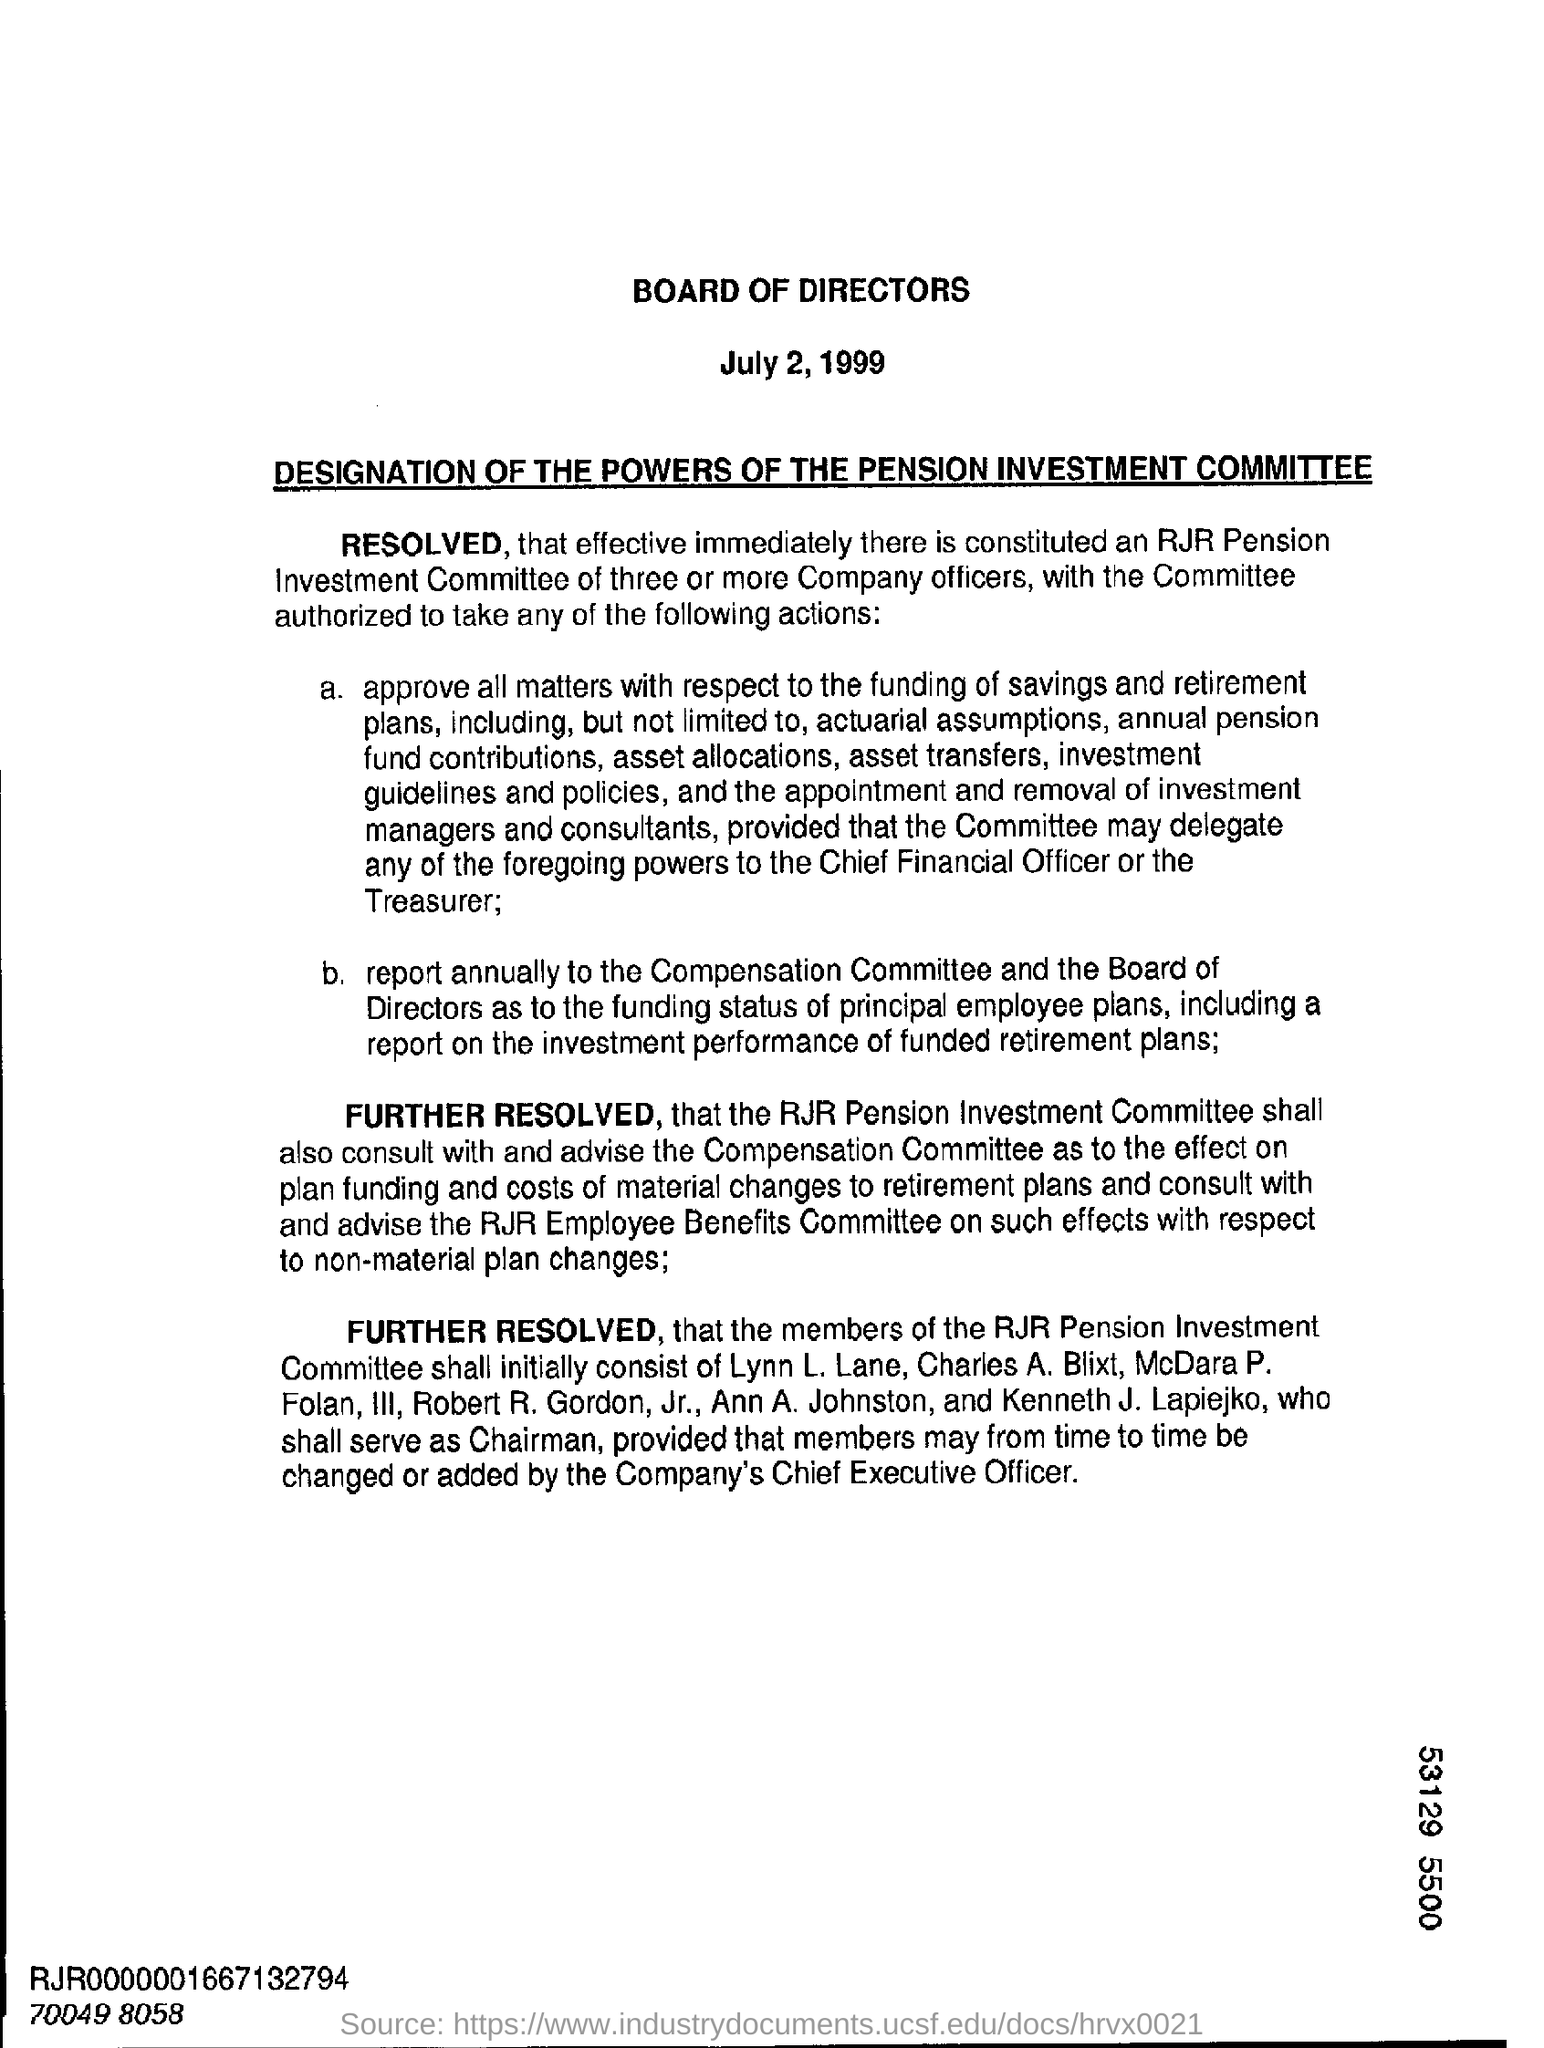What is the date on the document?
Ensure brevity in your answer.  July 2, 1999. Who shall serve as chairman?
Make the answer very short. Kenneth J. Lapiejko. 